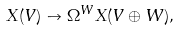Convert formula to latex. <formula><loc_0><loc_0><loc_500><loc_500>X ( V ) \to \Omega ^ { W } X ( V \oplus W ) ,</formula> 